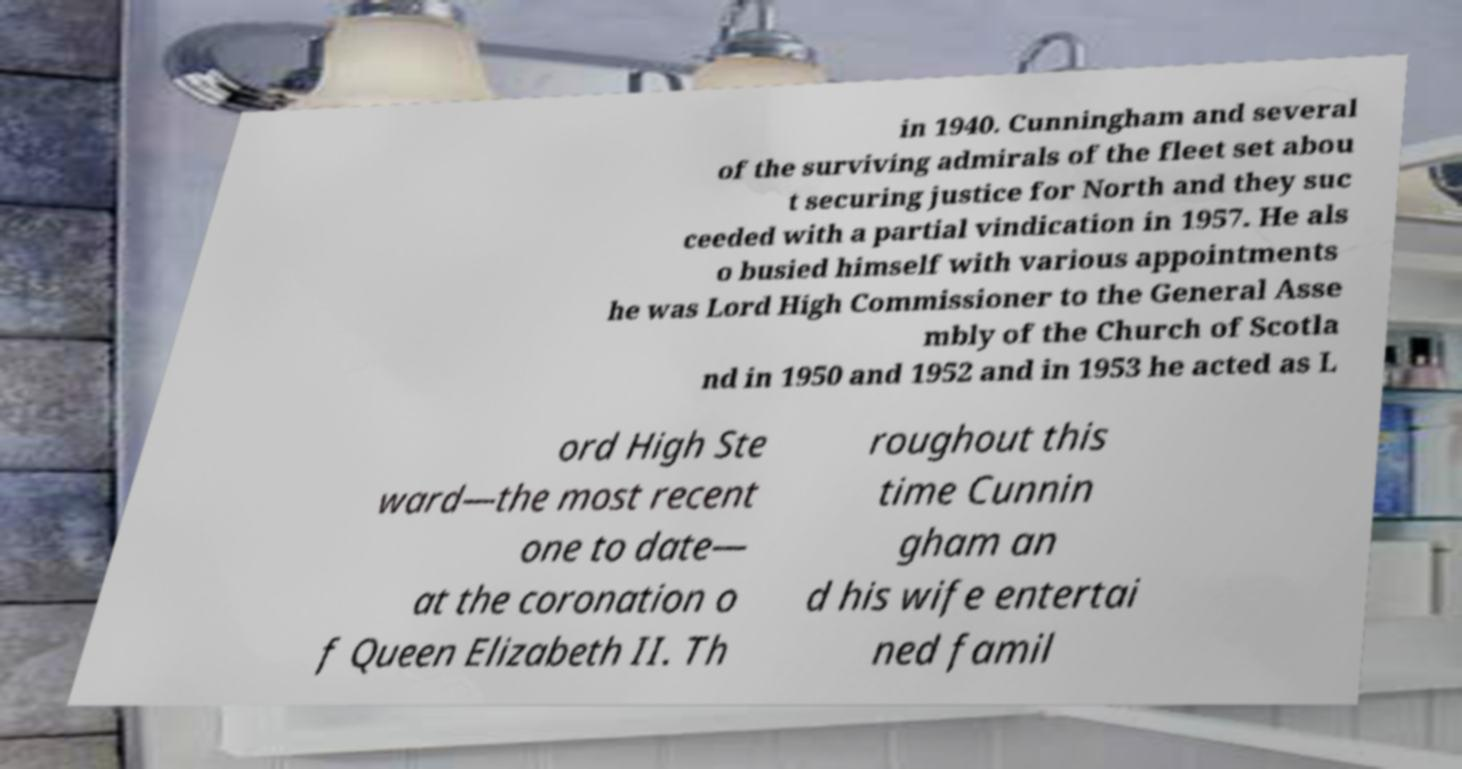Please read and relay the text visible in this image. What does it say? in 1940. Cunningham and several of the surviving admirals of the fleet set abou t securing justice for North and they suc ceeded with a partial vindication in 1957. He als o busied himself with various appointments he was Lord High Commissioner to the General Asse mbly of the Church of Scotla nd in 1950 and 1952 and in 1953 he acted as L ord High Ste ward—the most recent one to date— at the coronation o f Queen Elizabeth II. Th roughout this time Cunnin gham an d his wife entertai ned famil 